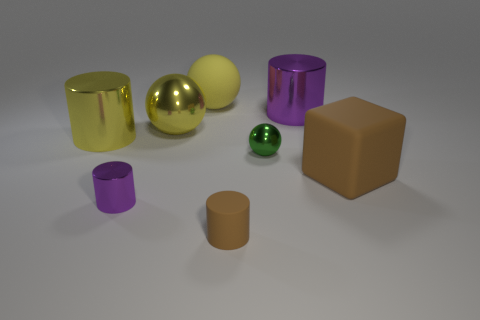Subtract all yellow balls. How many purple cylinders are left? 2 Subtract all big shiny balls. How many balls are left? 2 Add 1 tiny balls. How many objects exist? 9 Subtract all brown cylinders. How many cylinders are left? 3 Subtract all spheres. How many objects are left? 5 Subtract 1 spheres. How many spheres are left? 2 Subtract all blue cylinders. Subtract all purple blocks. How many cylinders are left? 4 Subtract all purple cylinders. Subtract all tiny yellow matte blocks. How many objects are left? 6 Add 4 yellow shiny cylinders. How many yellow shiny cylinders are left? 5 Add 3 tiny rubber objects. How many tiny rubber objects exist? 4 